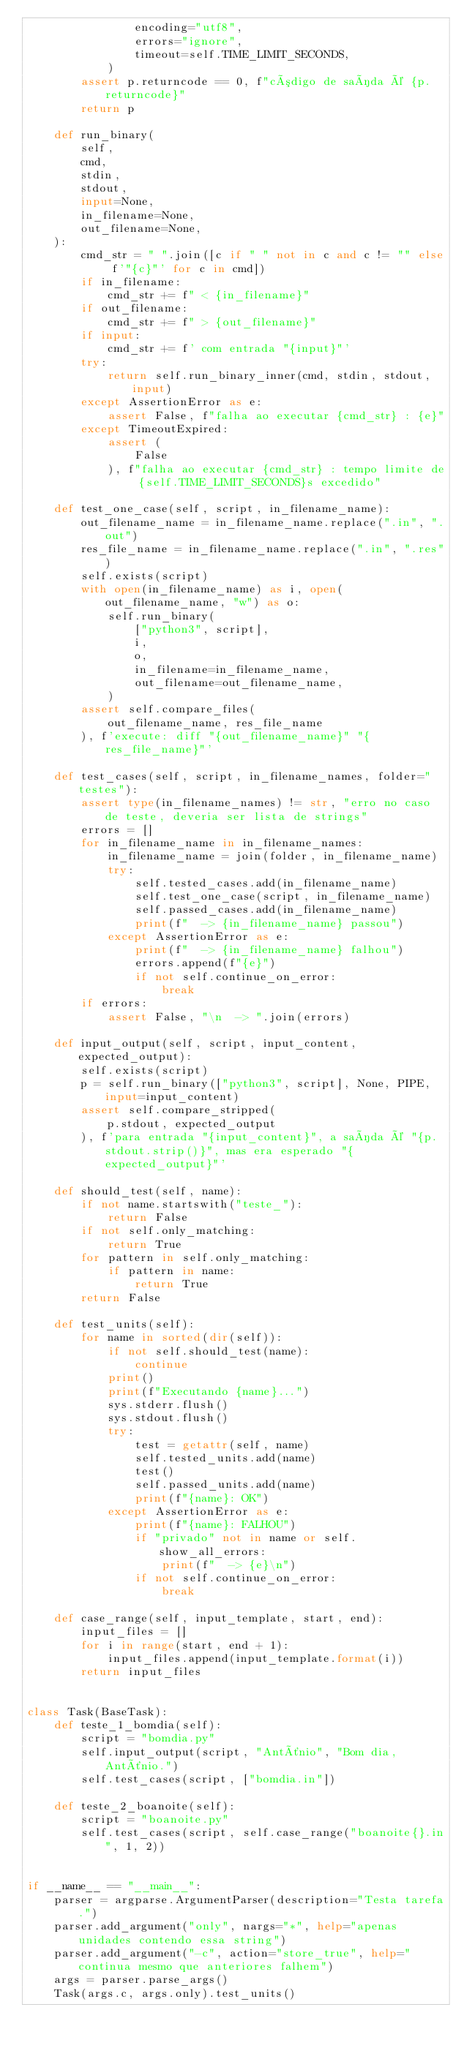<code> <loc_0><loc_0><loc_500><loc_500><_Python_>                encoding="utf8",
                errors="ignore",
                timeout=self.TIME_LIMIT_SECONDS,
            )
        assert p.returncode == 0, f"código de saída é {p.returncode}"
        return p

    def run_binary(
        self,
        cmd,
        stdin,
        stdout,
        input=None,
        in_filename=None,
        out_filename=None,
    ):
        cmd_str = " ".join([c if " " not in c and c != "" else f'"{c}"' for c in cmd])
        if in_filename:
            cmd_str += f" < {in_filename}"
        if out_filename:
            cmd_str += f" > {out_filename}"
        if input:
            cmd_str += f' com entrada "{input}"'
        try:
            return self.run_binary_inner(cmd, stdin, stdout, input)
        except AssertionError as e:
            assert False, f"falha ao executar {cmd_str} : {e}"
        except TimeoutExpired:
            assert (
                False
            ), f"falha ao executar {cmd_str} : tempo limite de {self.TIME_LIMIT_SECONDS}s excedido"

    def test_one_case(self, script, in_filename_name):
        out_filename_name = in_filename_name.replace(".in", ".out")
        res_file_name = in_filename_name.replace(".in", ".res")
        self.exists(script)
        with open(in_filename_name) as i, open(out_filename_name, "w") as o:
            self.run_binary(
                ["python3", script],
                i,
                o,
                in_filename=in_filename_name,
                out_filename=out_filename_name,
            )
        assert self.compare_files(
            out_filename_name, res_file_name
        ), f'execute: diff "{out_filename_name}" "{res_file_name}"'

    def test_cases(self, script, in_filename_names, folder="testes"):
        assert type(in_filename_names) != str, "erro no caso de teste, deveria ser lista de strings"
        errors = []
        for in_filename_name in in_filename_names:
            in_filename_name = join(folder, in_filename_name)
            try:
                self.tested_cases.add(in_filename_name)
                self.test_one_case(script, in_filename_name)
                self.passed_cases.add(in_filename_name)
                print(f"  -> {in_filename_name} passou")
            except AssertionError as e:
                print(f"  -> {in_filename_name} falhou")
                errors.append(f"{e}")
                if not self.continue_on_error:
                    break
        if errors:
            assert False, "\n  -> ".join(errors)

    def input_output(self, script, input_content, expected_output):
        self.exists(script)
        p = self.run_binary(["python3", script], None, PIPE, input=input_content)
        assert self.compare_stripped(
            p.stdout, expected_output
        ), f'para entrada "{input_content}", a saída é "{p.stdout.strip()}", mas era esperado "{expected_output}"'

    def should_test(self, name):
        if not name.startswith("teste_"):
            return False
        if not self.only_matching:
            return True
        for pattern in self.only_matching:
            if pattern in name:
                return True
        return False

    def test_units(self):
        for name in sorted(dir(self)):
            if not self.should_test(name):
                continue
            print()
            print(f"Executando {name}...")
            sys.stderr.flush()
            sys.stdout.flush()
            try:
                test = getattr(self, name)
                self.tested_units.add(name)
                test()
                self.passed_units.add(name)
                print(f"{name}: OK")
            except AssertionError as e:
                print(f"{name}: FALHOU")
                if "privado" not in name or self.show_all_errors:
                    print(f"  -> {e}\n")
                if not self.continue_on_error:
                    break

    def case_range(self, input_template, start, end):
        input_files = []
        for i in range(start, end + 1):
            input_files.append(input_template.format(i))
        return input_files


class Task(BaseTask):
    def teste_1_bomdia(self):
        script = "bomdia.py"
        self.input_output(script, "Antônio", "Bom dia, Antônio.")
        self.test_cases(script, ["bomdia.in"])

    def teste_2_boanoite(self):
        script = "boanoite.py"
        self.test_cases(script, self.case_range("boanoite{}.in", 1, 2))


if __name__ == "__main__":
    parser = argparse.ArgumentParser(description="Testa tarefa.")
    parser.add_argument("only", nargs="*", help="apenas unidades contendo essa string")
    parser.add_argument("-c", action="store_true", help="continua mesmo que anteriores falhem")
    args = parser.parse_args()
    Task(args.c, args.only).test_units()
</code> 